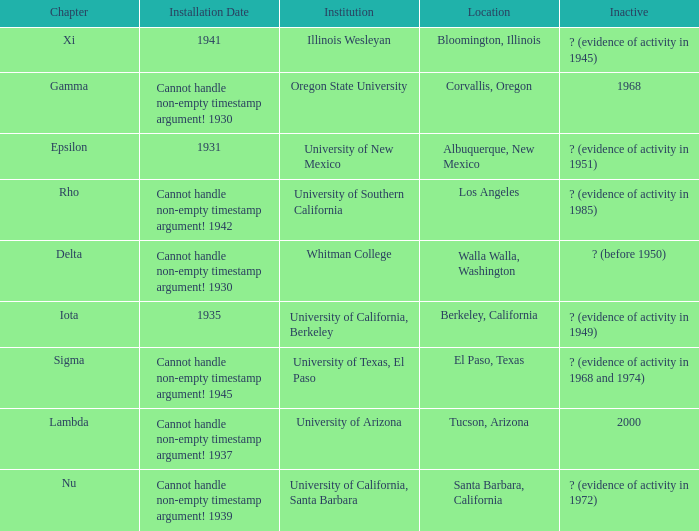What was the installation date in El Paso, Texas?  Cannot handle non-empty timestamp argument! 1945. Can you give me this table as a dict? {'header': ['Chapter', 'Installation Date', 'Institution', 'Location', 'Inactive'], 'rows': [['Xi', '1941', 'Illinois Wesleyan', 'Bloomington, Illinois', '? (evidence of activity in 1945)'], ['Gamma', 'Cannot handle non-empty timestamp argument! 1930', 'Oregon State University', 'Corvallis, Oregon', '1968'], ['Epsilon', '1931', 'University of New Mexico', 'Albuquerque, New Mexico', '? (evidence of activity in 1951)'], ['Rho', 'Cannot handle non-empty timestamp argument! 1942', 'University of Southern California', 'Los Angeles', '? (evidence of activity in 1985)'], ['Delta', 'Cannot handle non-empty timestamp argument! 1930', 'Whitman College', 'Walla Walla, Washington', '? (before 1950)'], ['Iota', '1935', 'University of California, Berkeley', 'Berkeley, California', '? (evidence of activity in 1949)'], ['Sigma', 'Cannot handle non-empty timestamp argument! 1945', 'University of Texas, El Paso', 'El Paso, Texas', '? (evidence of activity in 1968 and 1974)'], ['Lambda', 'Cannot handle non-empty timestamp argument! 1937', 'University of Arizona', 'Tucson, Arizona', '2000'], ['Nu', 'Cannot handle non-empty timestamp argument! 1939', 'University of California, Santa Barbara', 'Santa Barbara, California', '? (evidence of activity in 1972)']]} 